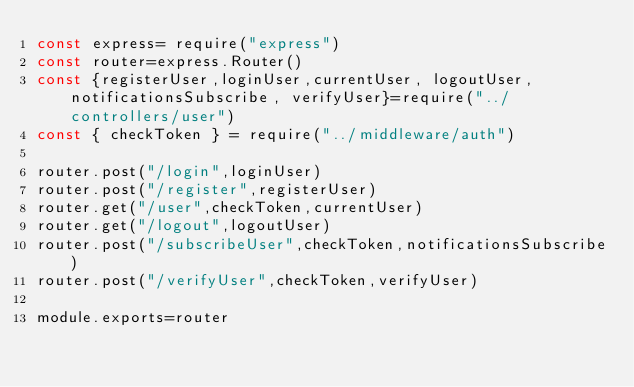<code> <loc_0><loc_0><loc_500><loc_500><_JavaScript_>const express= require("express")
const router=express.Router()
const {registerUser,loginUser,currentUser, logoutUser, notificationsSubscribe, verifyUser}=require("../controllers/user")
const { checkToken } = require("../middleware/auth")

router.post("/login",loginUser)
router.post("/register",registerUser)
router.get("/user",checkToken,currentUser)
router.get("/logout",logoutUser)
router.post("/subscribeUser",checkToken,notificationsSubscribe)
router.post("/verifyUser",checkToken,verifyUser)

module.exports=router</code> 